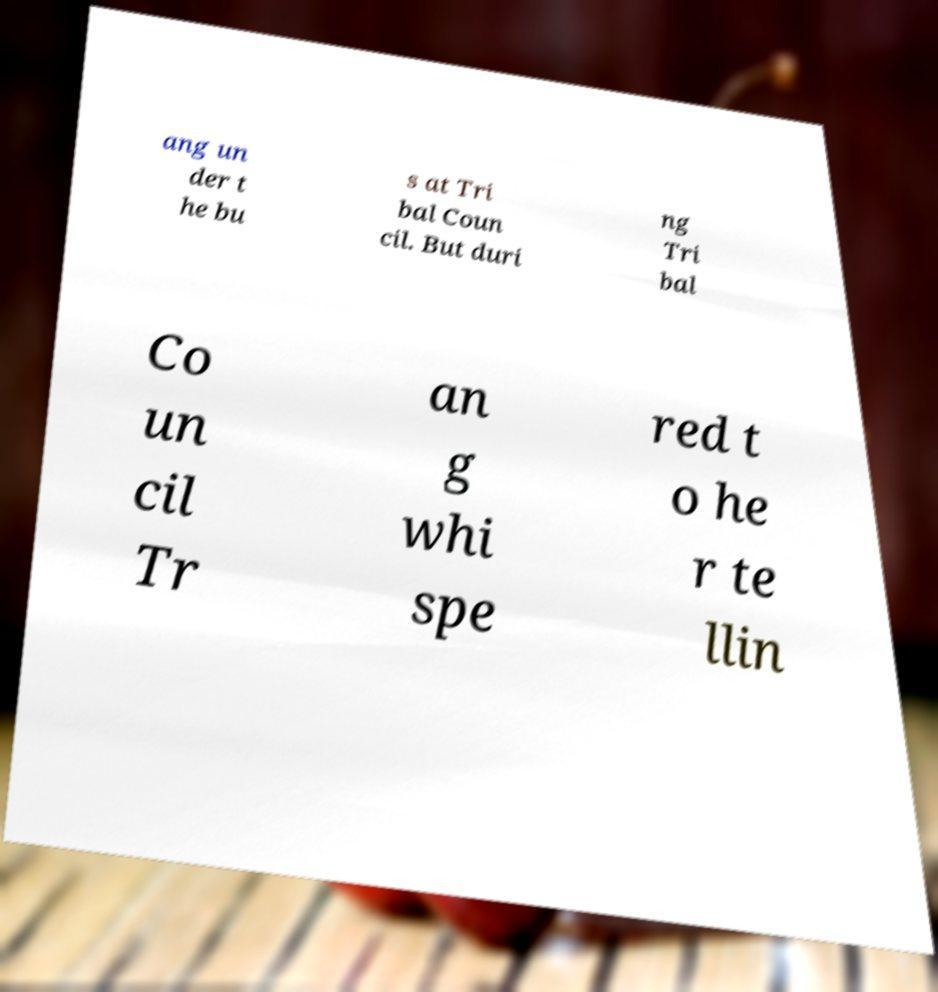Can you read and provide the text displayed in the image?This photo seems to have some interesting text. Can you extract and type it out for me? ang un der t he bu s at Tri bal Coun cil. But duri ng Tri bal Co un cil Tr an g whi spe red t o he r te llin 